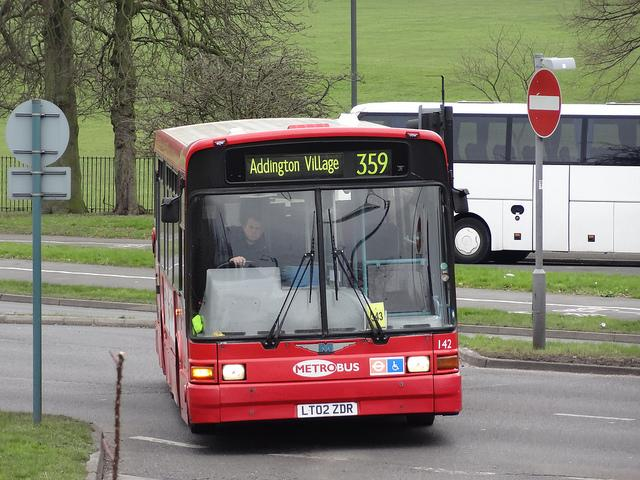What type of information is on the digital bus sign?

Choices:
A) brand
B) informational
C) directional
D) warning informational 